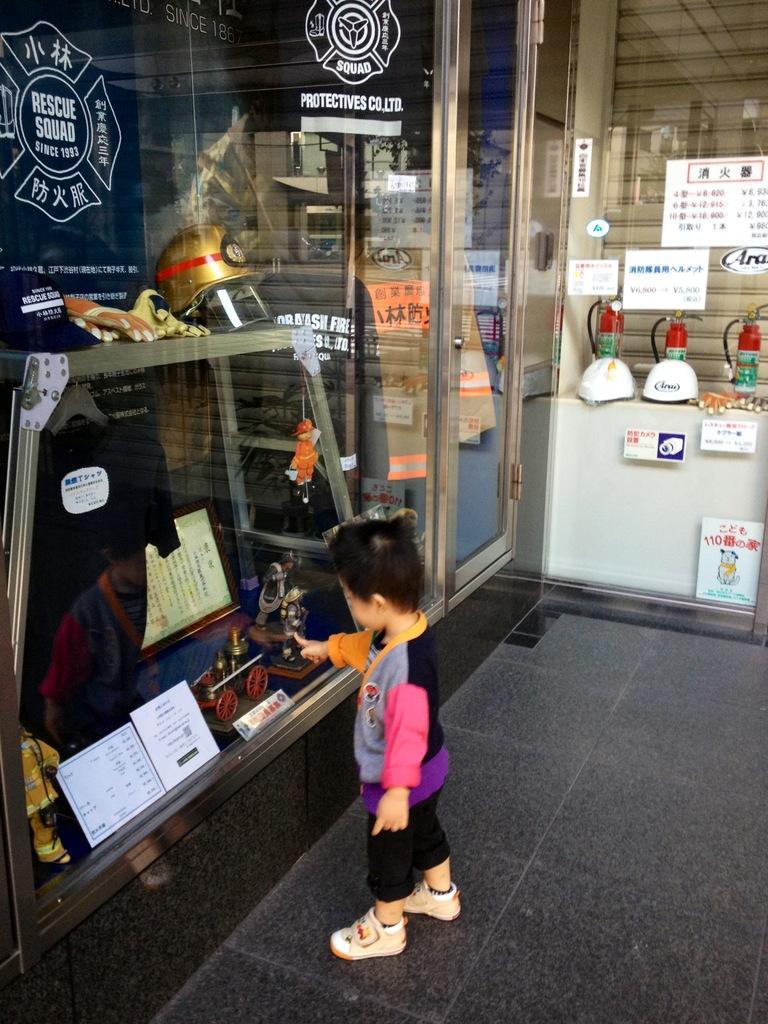Describe this image in one or two sentences. In this image, I can see a kid standing on the floor. On the left side of the image, I can see a helmet, gloves, T-shirt, photo frame, papers, toys and few other objects behind a glass door. At the top of the image, I can see a logo and words on a glass door. On the right side of the image, there are fire extinguishers and helmets. I can see the posts attached to a glass door. 